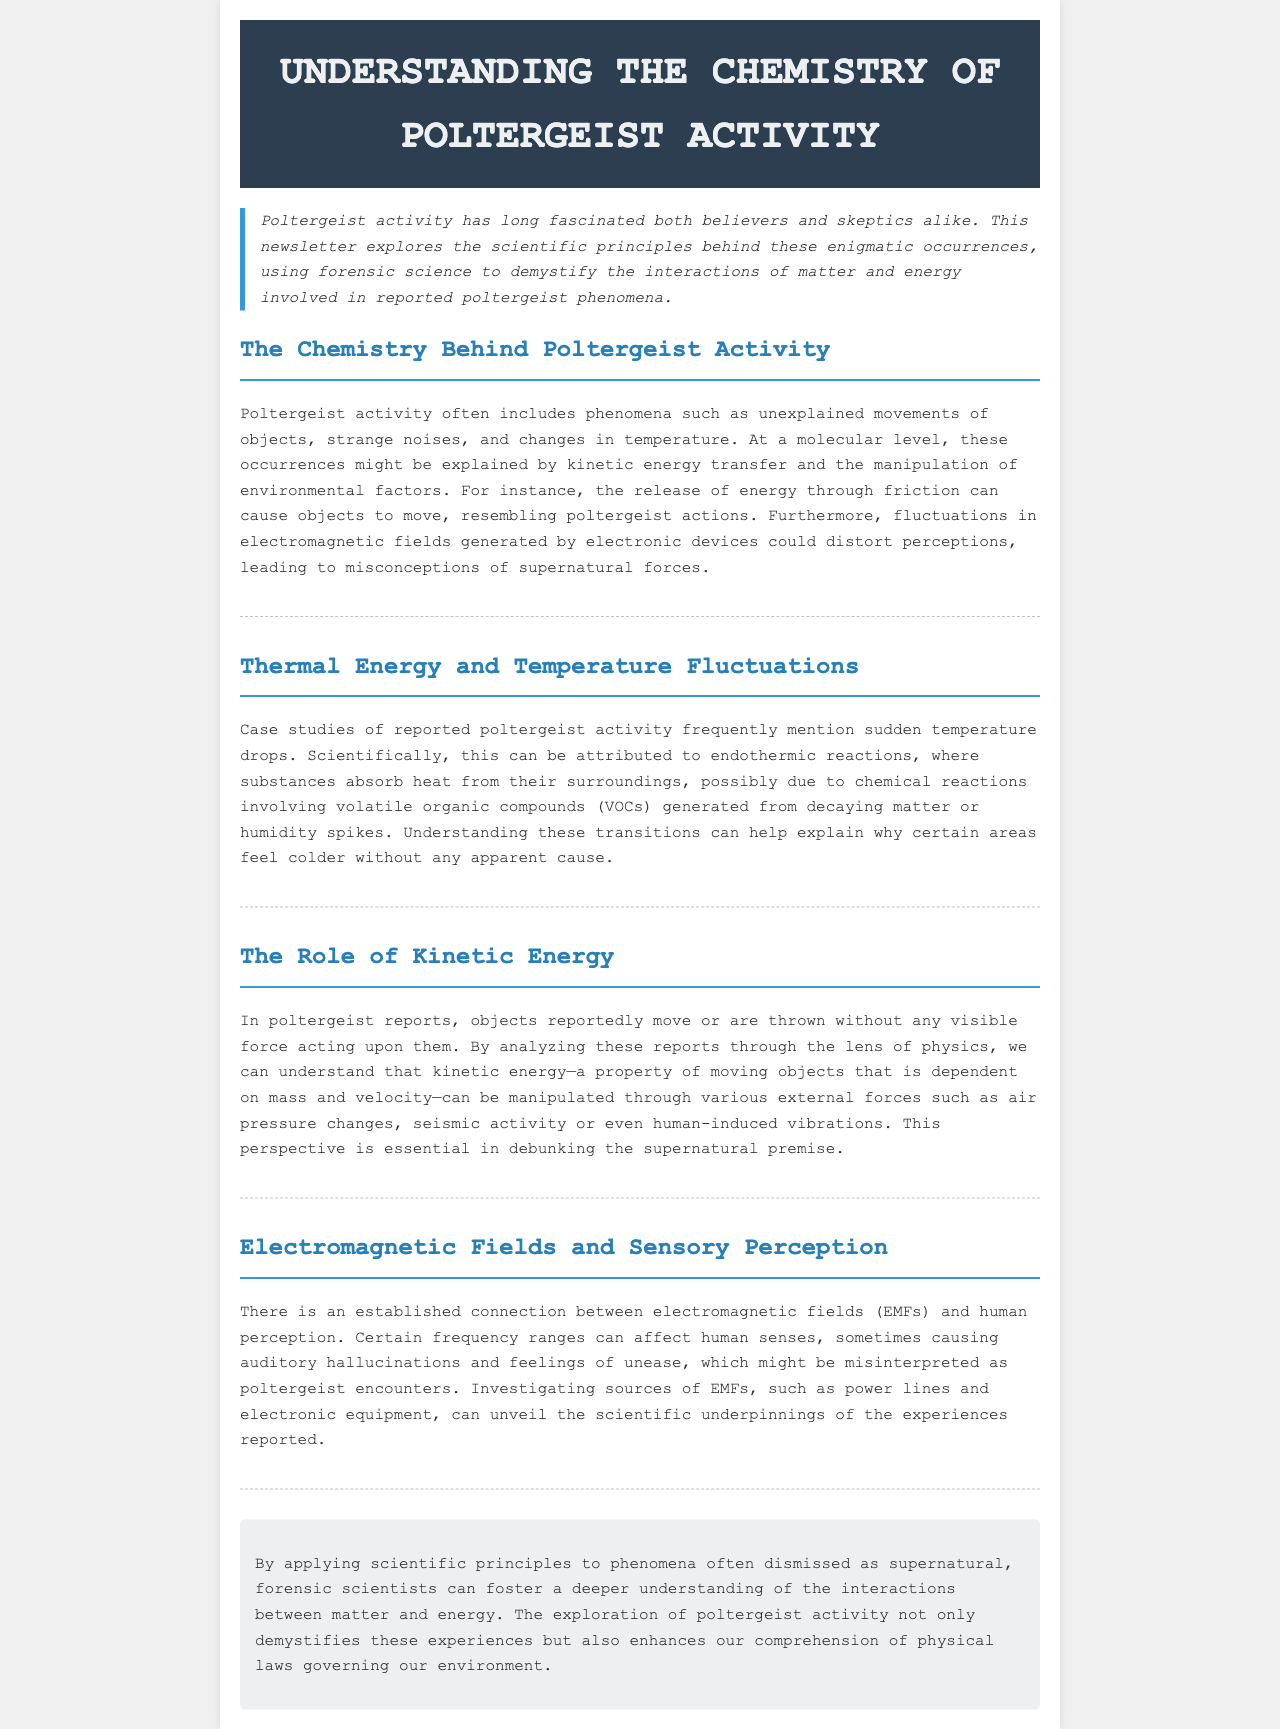What is the main subject of the newsletter? The main subject of the newsletter is the scientific exploration of poltergeist activity and its explanations.
Answer: Poltergeist activity What type of reactions are discussed in relation to temperature drops? The newsletter mentions endothermic reactions as a scientific explanation for temperature drops in poltergeist activity reports.
Answer: Endothermic reactions What can cause the unexplained movement of objects according to the document? The document explains that kinetic energy and external forces such as air pressure changes can cause the movement of objects.
Answer: Kinetic energy Which sources of electromagnetic fields are mentioned? The newsletter references power lines and electronic equipment as sources of electromagnetic fields that can affect human perception.
Answer: Power lines and electronic equipment What are VOCs in the context of the newsletter? Volatile organic compounds (VOCs) refer to substances that may absorb heat from surroundings, impacting temperature in reported poltergeist activity.
Answer: Volatile organic compounds How do EMFs relate to human senses? EMFs can affect human senses, potentially leading to auditory hallucinations and feelings of unease, mistaken as paranormal experiences.
Answer: Affecting human senses What does the newsletter aim to demystify? The newsletter aims to demystify experiences commonly attributed to supernatural forces by applying scientific principles.
Answer: Supernatural forces Which scientific field is emphasized in analyzing poltergeist phenomena? The newsletter emphasizes forensic science as the scientific field used to analyze poltergeist phenomena.
Answer: Forensic science 